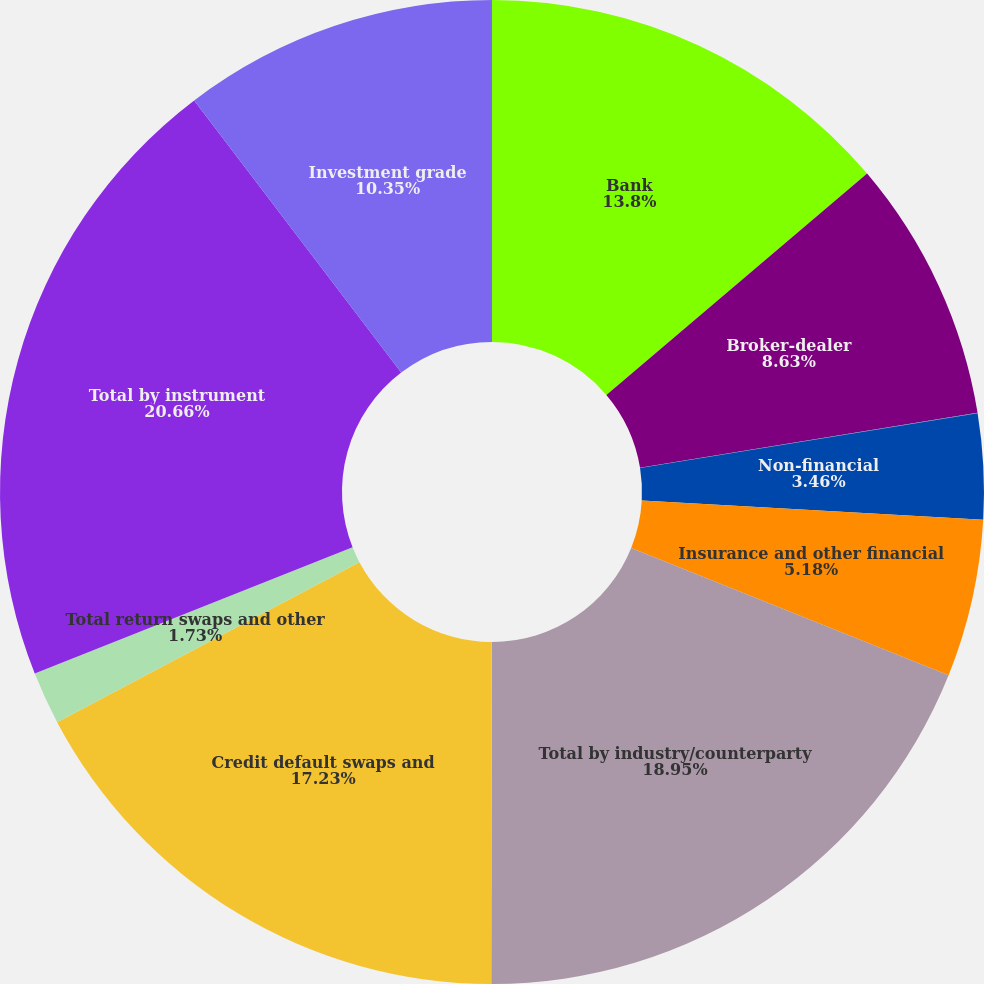Convert chart. <chart><loc_0><loc_0><loc_500><loc_500><pie_chart><fcel>Bank<fcel>Broker-dealer<fcel>Monoline<fcel>Non-financial<fcel>Insurance and other financial<fcel>Total by industry/counterparty<fcel>Credit default swaps and<fcel>Total return swaps and other<fcel>Total by instrument<fcel>Investment grade<nl><fcel>13.8%<fcel>8.63%<fcel>0.01%<fcel>3.46%<fcel>5.18%<fcel>18.95%<fcel>17.23%<fcel>1.73%<fcel>20.67%<fcel>10.35%<nl></chart> 